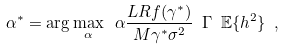Convert formula to latex. <formula><loc_0><loc_0><loc_500><loc_500>\alpha ^ { * } = \arg \max _ { \alpha } \ \alpha \frac { L R f ( \gamma ^ { * } ) } { M \gamma ^ { * } \sigma ^ { 2 } } \ \Gamma \ { \mathbb { E } } \{ h ^ { 2 } \} \ ,</formula> 